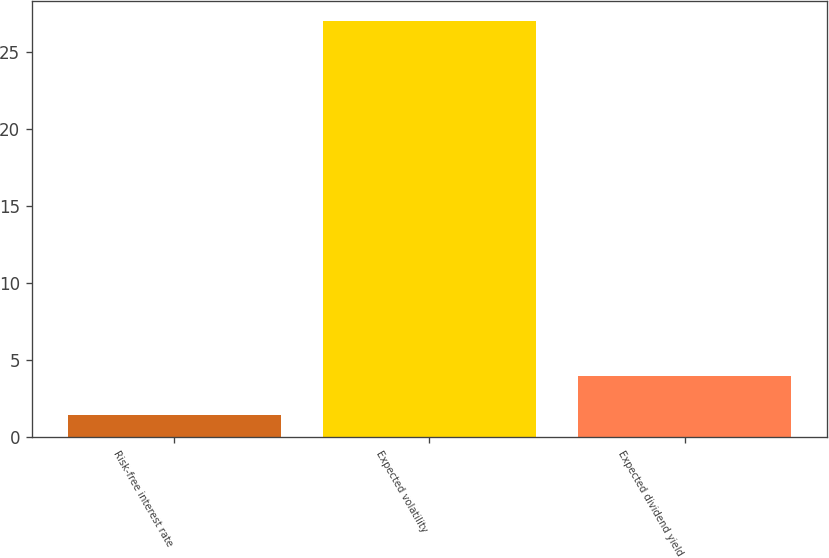Convert chart to OTSL. <chart><loc_0><loc_0><loc_500><loc_500><bar_chart><fcel>Risk-free interest rate<fcel>Expected volatility<fcel>Expected dividend yield<nl><fcel>1.4<fcel>27<fcel>3.96<nl></chart> 